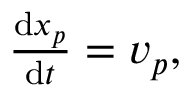Convert formula to latex. <formula><loc_0><loc_0><loc_500><loc_500>\begin{array} { r } { \frac { d x _ { p } } { d t } = v _ { p } , } \end{array}</formula> 